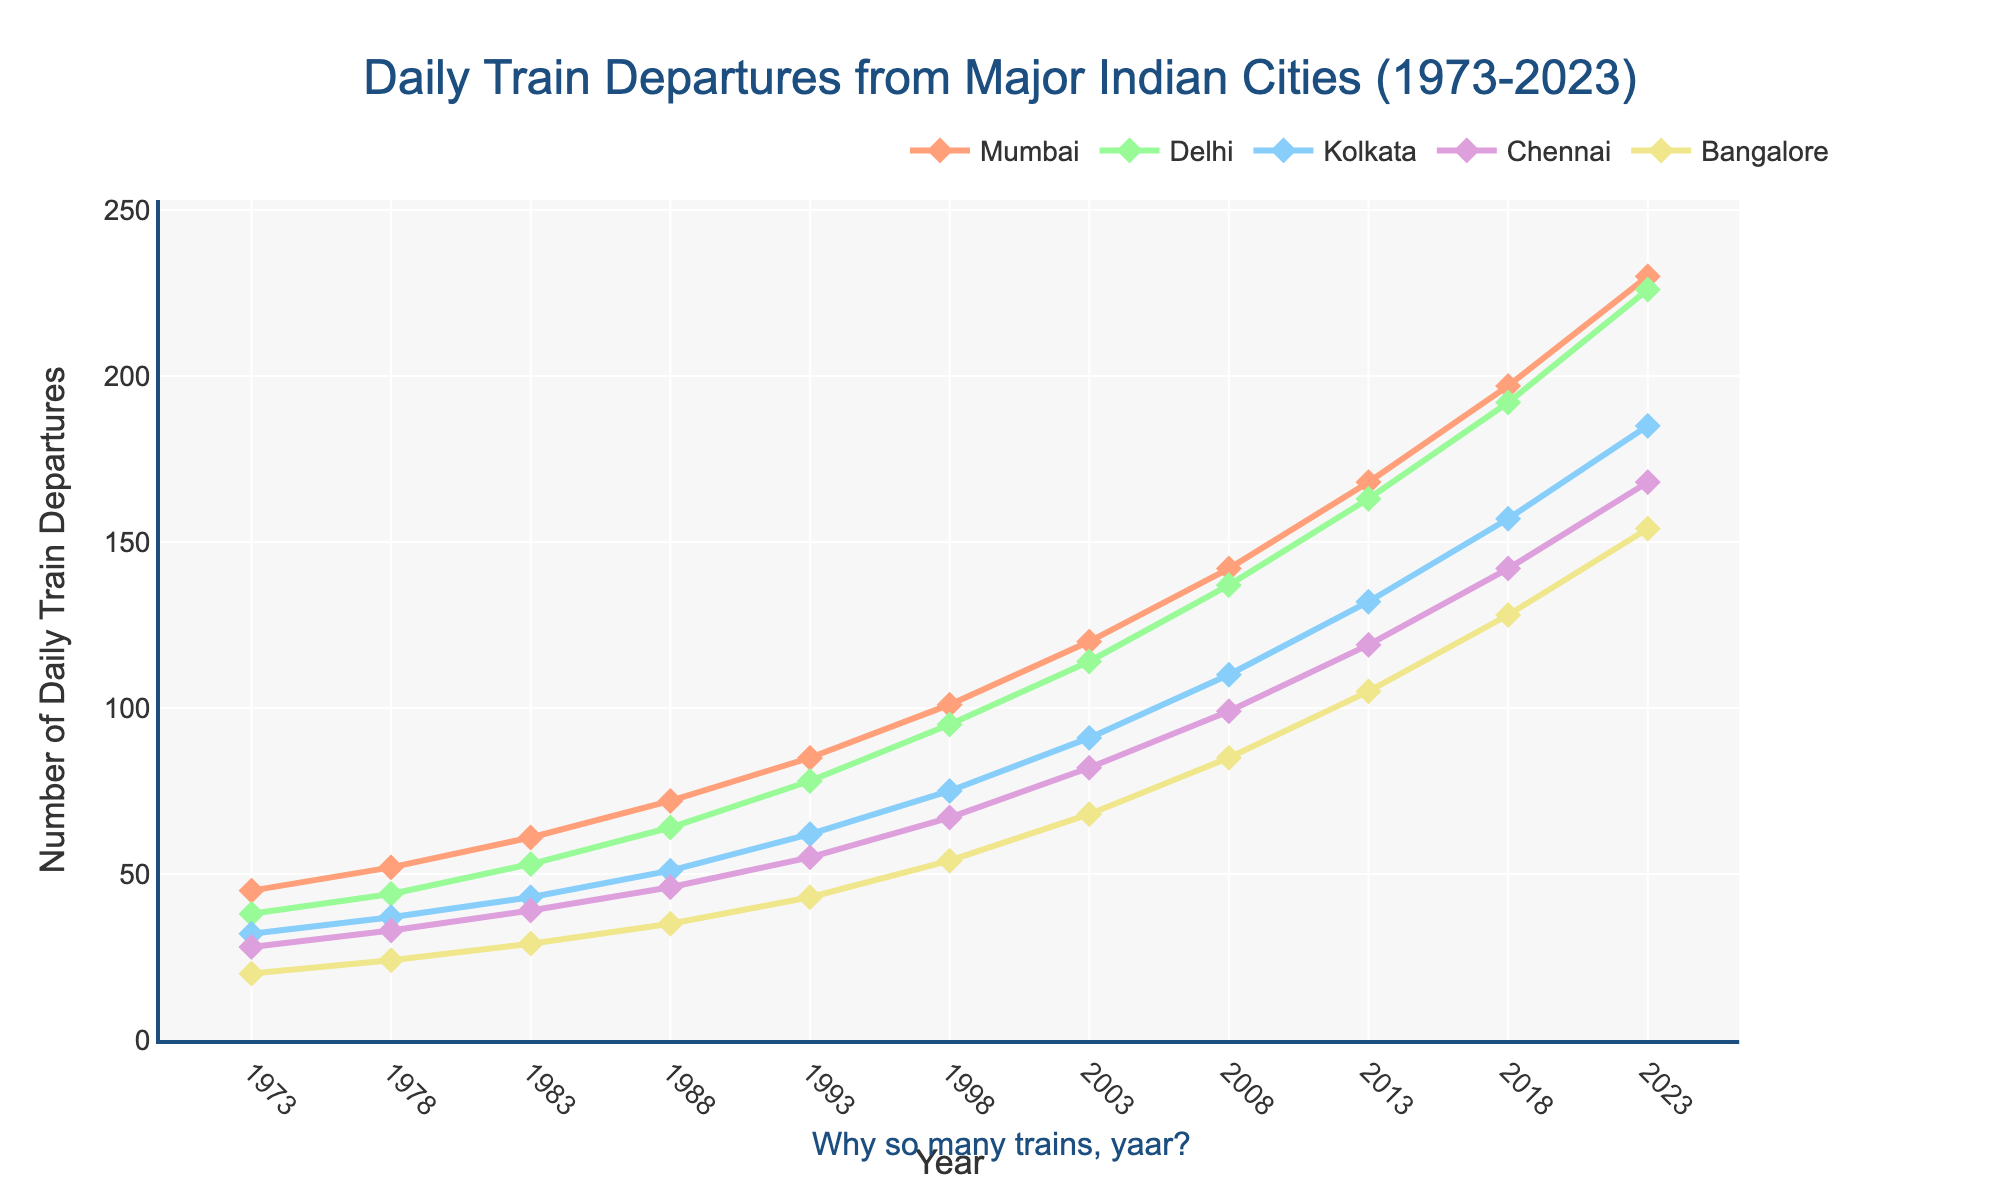Which city had the highest number of daily train departures in 2023? By observing the endpoints of the lines in the graph for the year 2023, we can see the city with the highest number of departures. Mumbai's endpoint is above the other cities, indicating the highest number of departures.
Answer: Mumbai Which city showed the most significant increase in the number of daily train departures from 1973 to 2023? To determine the most significant increase, compare the numerical increase for each city by subtracting the 1973 value from the 2023 value. For Mumbai: 230 - 45 = 185, Delhi: 226 - 38 = 188, Kolkata: 185 - 32 = 153, Chennai: 168 - 28 = 140, Bangalore: 154 - 20 = 134. Delhi has the largest increase (188).
Answer: Delhi In which year did Bangalore see the first significant jump in the number of daily train departures compared to previous years? Looking at the chart, note the years where the line for Bangalore shows visible upward jumps. There appears to be a notable increase between 1973 and 1978, where the departures increase from 20 to 24. This is the first significant rise.
Answer: 1978 Between which years did Chennai see the least increase in daily train departures? Examine the segments of the Chennai line between each consecutive pair of years. The smallest vertical change comes between 1973 and 1978 (28 to 33) which is an increase of 5 departures.
Answer: 1973 to 1978 What is the average number of daily train departures for Kolkata over the years shown? To calculate the average, sum all the data points for Kolkata and divide by the number of points. The values are 32, 37, 43, 51, 62, 75, 91, 110, 132, 157, 185. Sum is 974. There are 11 data points, so the average is 974 / 11 = 88.55
Answer: 88.55 Which city had the lowest number of daily train departures in 2013? Identify the points corresponding to 2013 for each city and find the lowest one. Mumbai: 168, Delhi: 163, Kolkata: 132, Chennai: 119, Bangalore: 105. Bangalore has the lowest value in 2013.
Answer: Bangalore By how much did the daily train departures for Mumbai increase from 1998 to 2003? Subtract the value in 1998 from the value in 2003 for Mumbai. 2003: 120, 1998: 101. 120 - 101 = 19
Answer: 19 How many years did it take for Delhi's daily train departures to exceed 100 starting from 1973? Find the year where Delhi's value first exceeds 100. It happens at 1998 (95). From 1973 to 1998, it takes 25 years.
Answer: 25 Which city maintained the most consistent rate of growth in train departures over the 50-year period? Observing the smoothness and consistent spacing of the line segments, Kolkata appears to have the most stable, steady increase without sharp jumps or drops.
Answer: Kolkata 